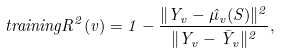Convert formula to latex. <formula><loc_0><loc_0><loc_500><loc_500>t r a i n i n g R ^ { 2 } ( v ) = 1 - \frac { \| Y _ { v } - \hat { \mu } _ { v } ( S ) \| ^ { 2 } } { \| Y _ { v } - \bar { Y } _ { v } \| ^ { 2 } } ,</formula> 